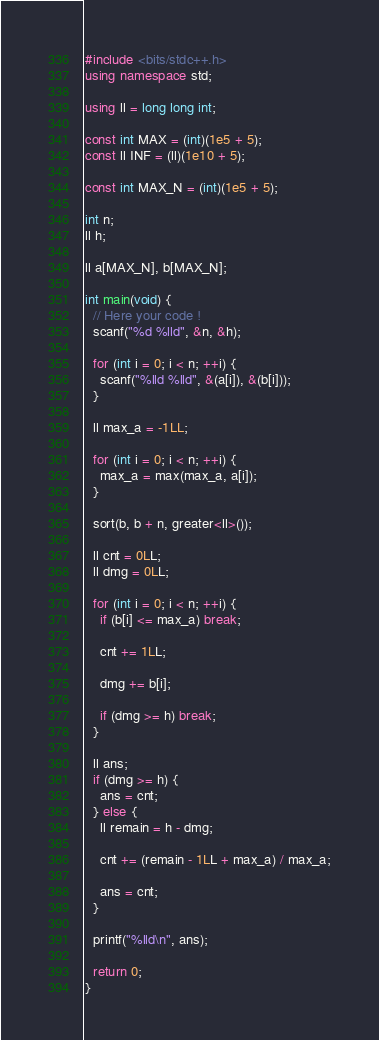<code> <loc_0><loc_0><loc_500><loc_500><_C++_>#include <bits/stdc++.h>
using namespace std;

using ll = long long int;

const int MAX = (int)(1e5 + 5);
const ll INF = (ll)(1e10 + 5);

const int MAX_N = (int)(1e5 + 5);

int n;
ll h;

ll a[MAX_N], b[MAX_N];

int main(void) {
  // Here your code !
  scanf("%d %lld", &n, &h);

  for (int i = 0; i < n; ++i) {
    scanf("%lld %lld", &(a[i]), &(b[i]));
  }

  ll max_a = -1LL;

  for (int i = 0; i < n; ++i) {
    max_a = max(max_a, a[i]);
  }

  sort(b, b + n, greater<ll>());

  ll cnt = 0LL;
  ll dmg = 0LL;

  for (int i = 0; i < n; ++i) {
    if (b[i] <= max_a) break;

    cnt += 1LL;

    dmg += b[i];

    if (dmg >= h) break;
  }

  ll ans;
  if (dmg >= h) {
    ans = cnt;
  } else {
    ll remain = h - dmg;

    cnt += (remain - 1LL + max_a) / max_a;

    ans = cnt;
  }

  printf("%lld\n", ans);

  return 0;
}
</code> 